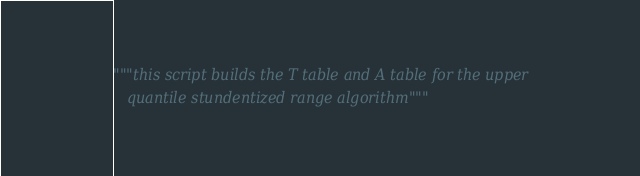Convert code to text. <code><loc_0><loc_0><loc_500><loc_500><_Python_>"""this script builds the T table and A table for the upper
   quantile stundentized range algorithm"""</code> 